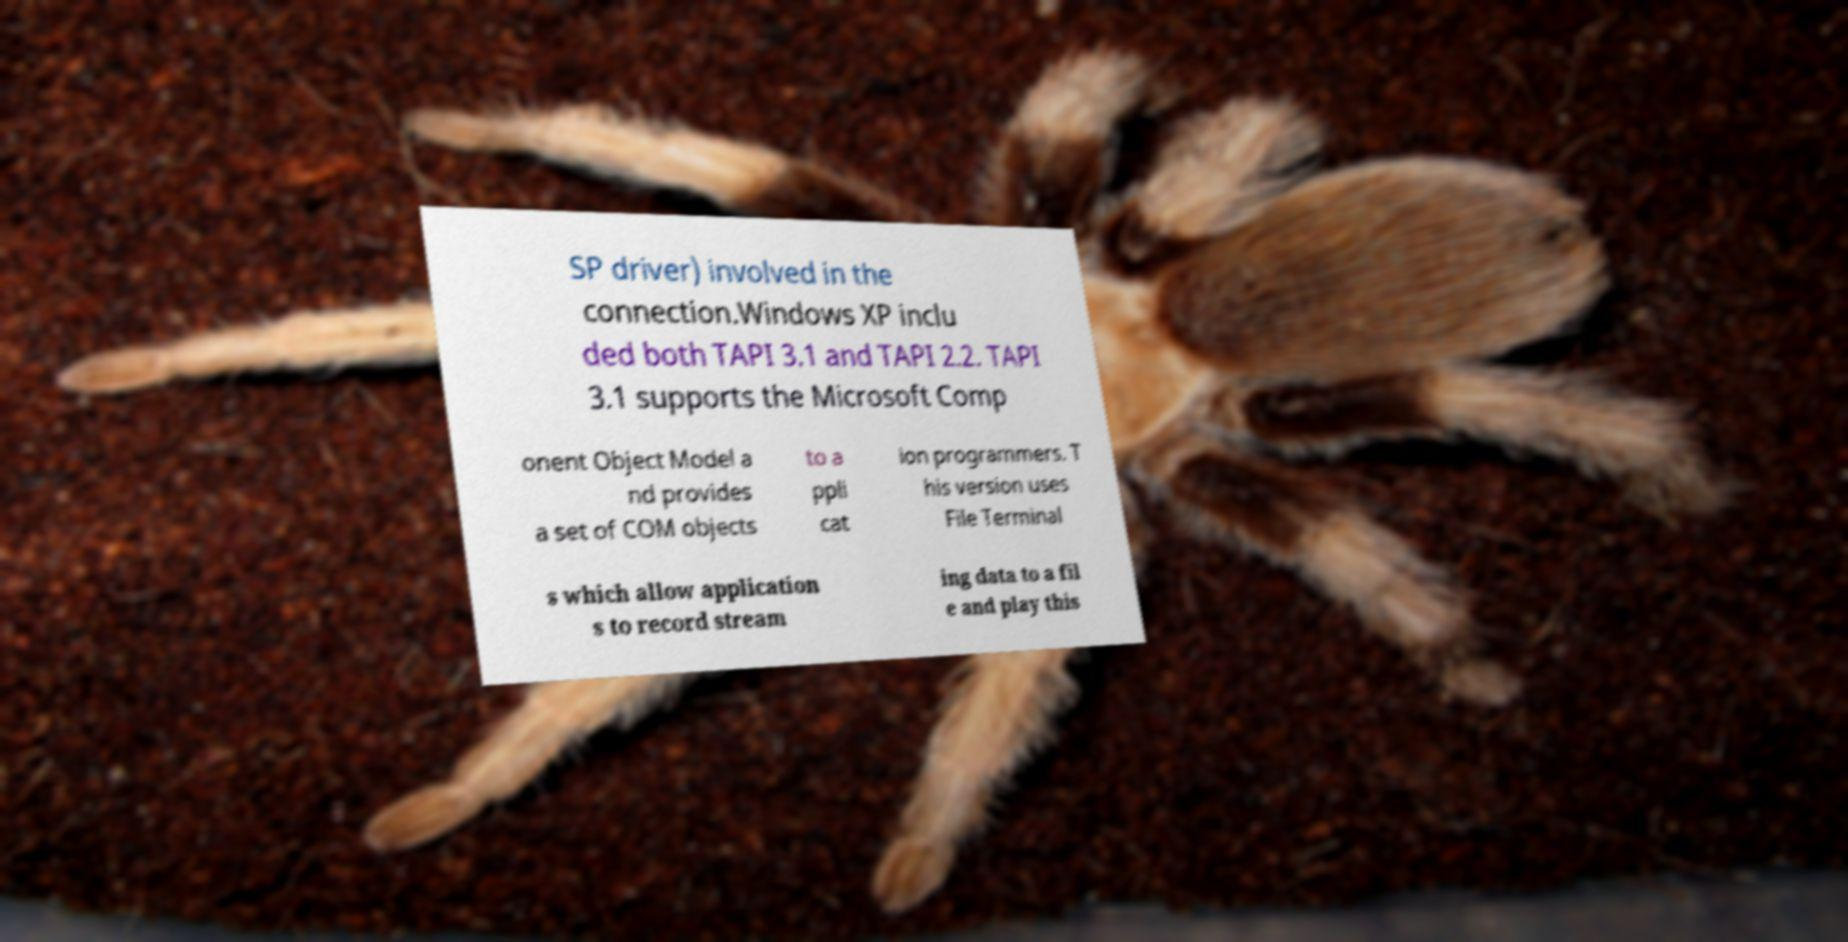I need the written content from this picture converted into text. Can you do that? SP driver) involved in the connection.Windows XP inclu ded both TAPI 3.1 and TAPI 2.2. TAPI 3.1 supports the Microsoft Comp onent Object Model a nd provides a set of COM objects to a ppli cat ion programmers. T his version uses File Terminal s which allow application s to record stream ing data to a fil e and play this 